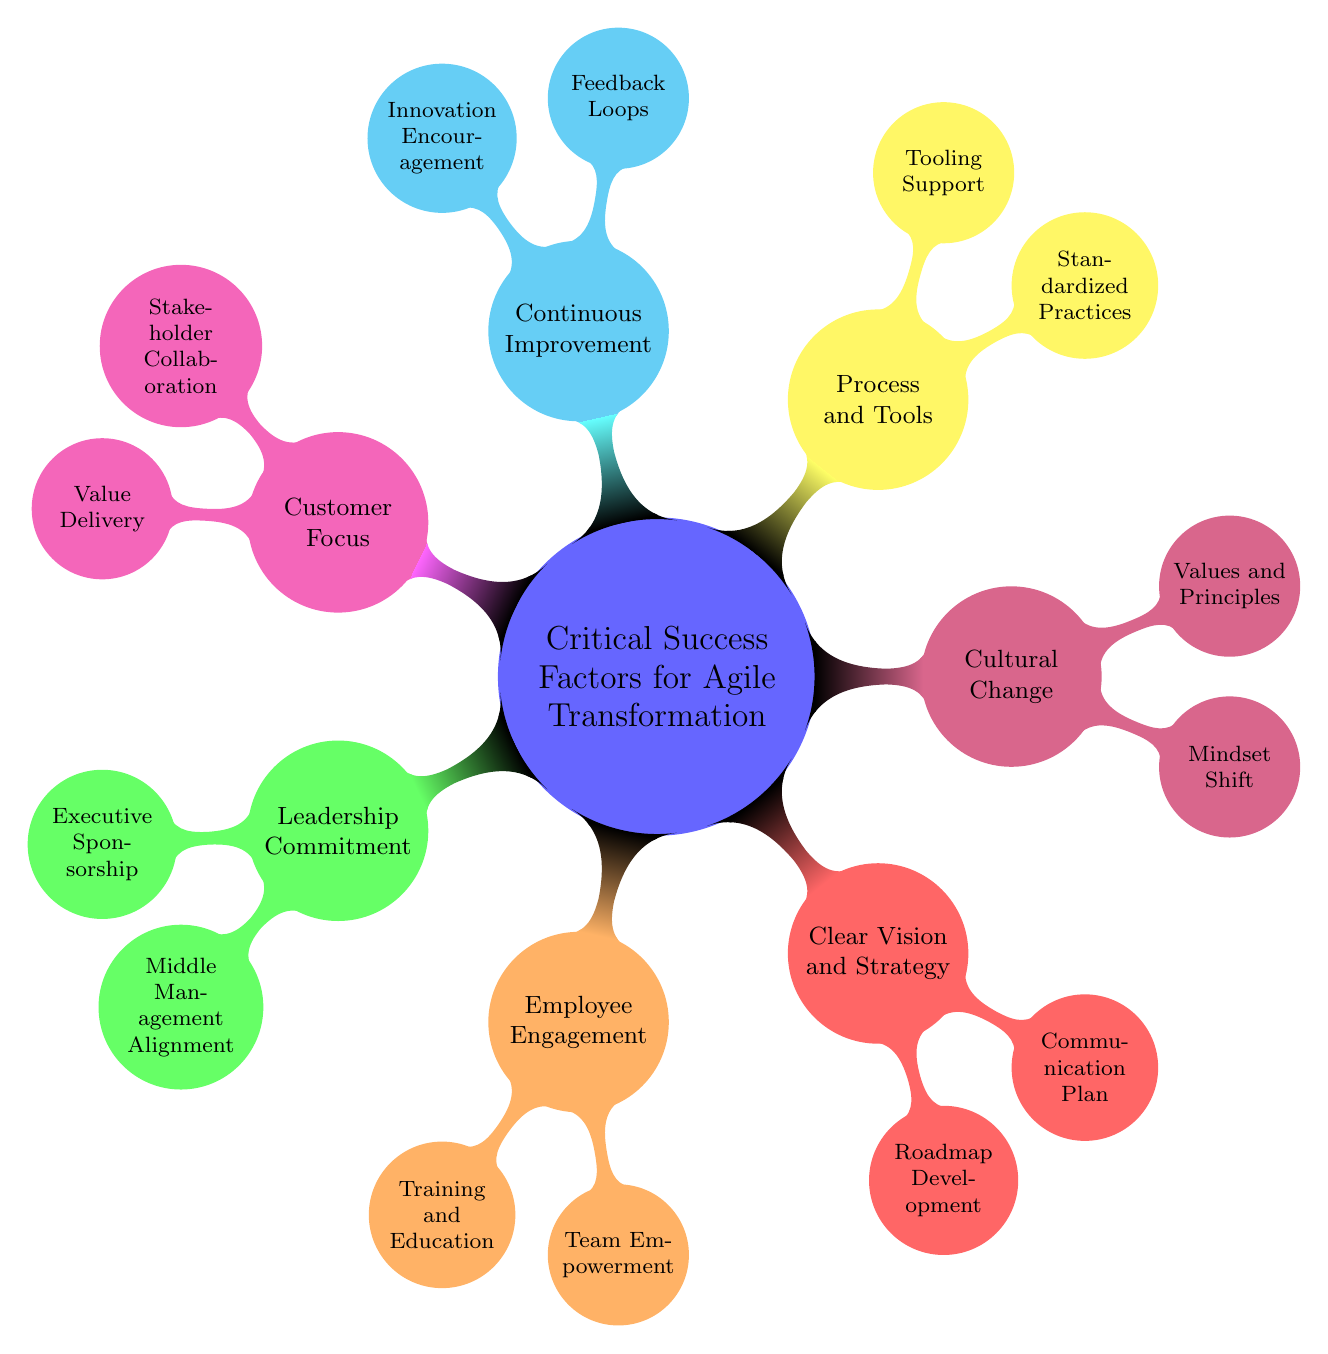What is the main theme of the mind map? The central node of the mind map defines the primary subject, which is "Critical Success Factors for Agile Transformation."
Answer: Critical Success Factors for Agile Transformation How many main branches are there in the mind map? The mind map contains seven main branches stemming from the central node: Leadership Commitment, Employee Engagement, Clear Vision and Strategy, Cultural Change, Process and Tools, Continuous Improvement, and Customer Focus. This can be counted directly from the diagram.
Answer: 7 What are two sub-nodes of Leadership Commitment? By inspecting the Leadership Commitment branch, we can identify its two sub-nodes: Executive Sponsorship and Middle Management Alignment.
Answer: Executive Sponsorship, Middle Management Alignment Which critical success factor focuses on regular feedback? The Continuous Improvement node explicitly mentions "Feedback Loops" as part of its sub-nodes, indicating its focus on regular feedback.
Answer: Continuous Improvement Which sub-node under Customer Focus emphasizes stakeholder involvement? The sub-node under Customer Focus that discusses stakeholder involvement is "Stakeholder Collaboration."
Answer: Stakeholder Collaboration What purpose does the "Training and Education" node serve? The "Training and Education" node under Employee Engagement indicates that it represents ongoing learning programs and workshops aimed at enhancing employees' skills and knowledge.
Answer: Ongoing learning programs and workshops How does the "Values and Principles" sub-node relate to cultural change? The "Values and Principles" node under Cultural Change depicts the embedding of agile values and principles into the company culture, thus directly relating to the overall theme of fostering a supportive agile environment.
Answer: Embedding agile values and principles into the company culture What is the focus of the "Innovation Encouragement" node? The "Innovation Encouragement" node under Continuous Improvement signifies the aim of creating opportunities for experimentation and innovation, thus promoting a culture of continuous enhancement.
Answer: Creating space for experimentation and innovation Which critical success factor mentions standardized methodologies? The "Process and Tools" node highlights the adoption of standardized practices like Scrum or Kanban that are essential in an agile transformation scenario.
Answer: Process and Tools 